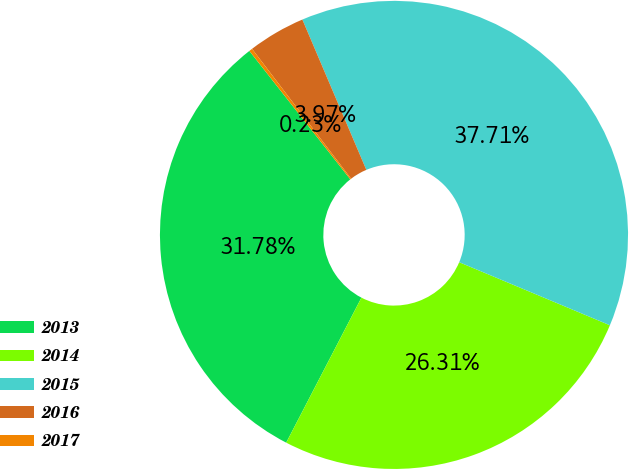Convert chart to OTSL. <chart><loc_0><loc_0><loc_500><loc_500><pie_chart><fcel>2013<fcel>2014<fcel>2015<fcel>2016<fcel>2017<nl><fcel>31.78%<fcel>26.31%<fcel>37.71%<fcel>3.97%<fcel>0.23%<nl></chart> 